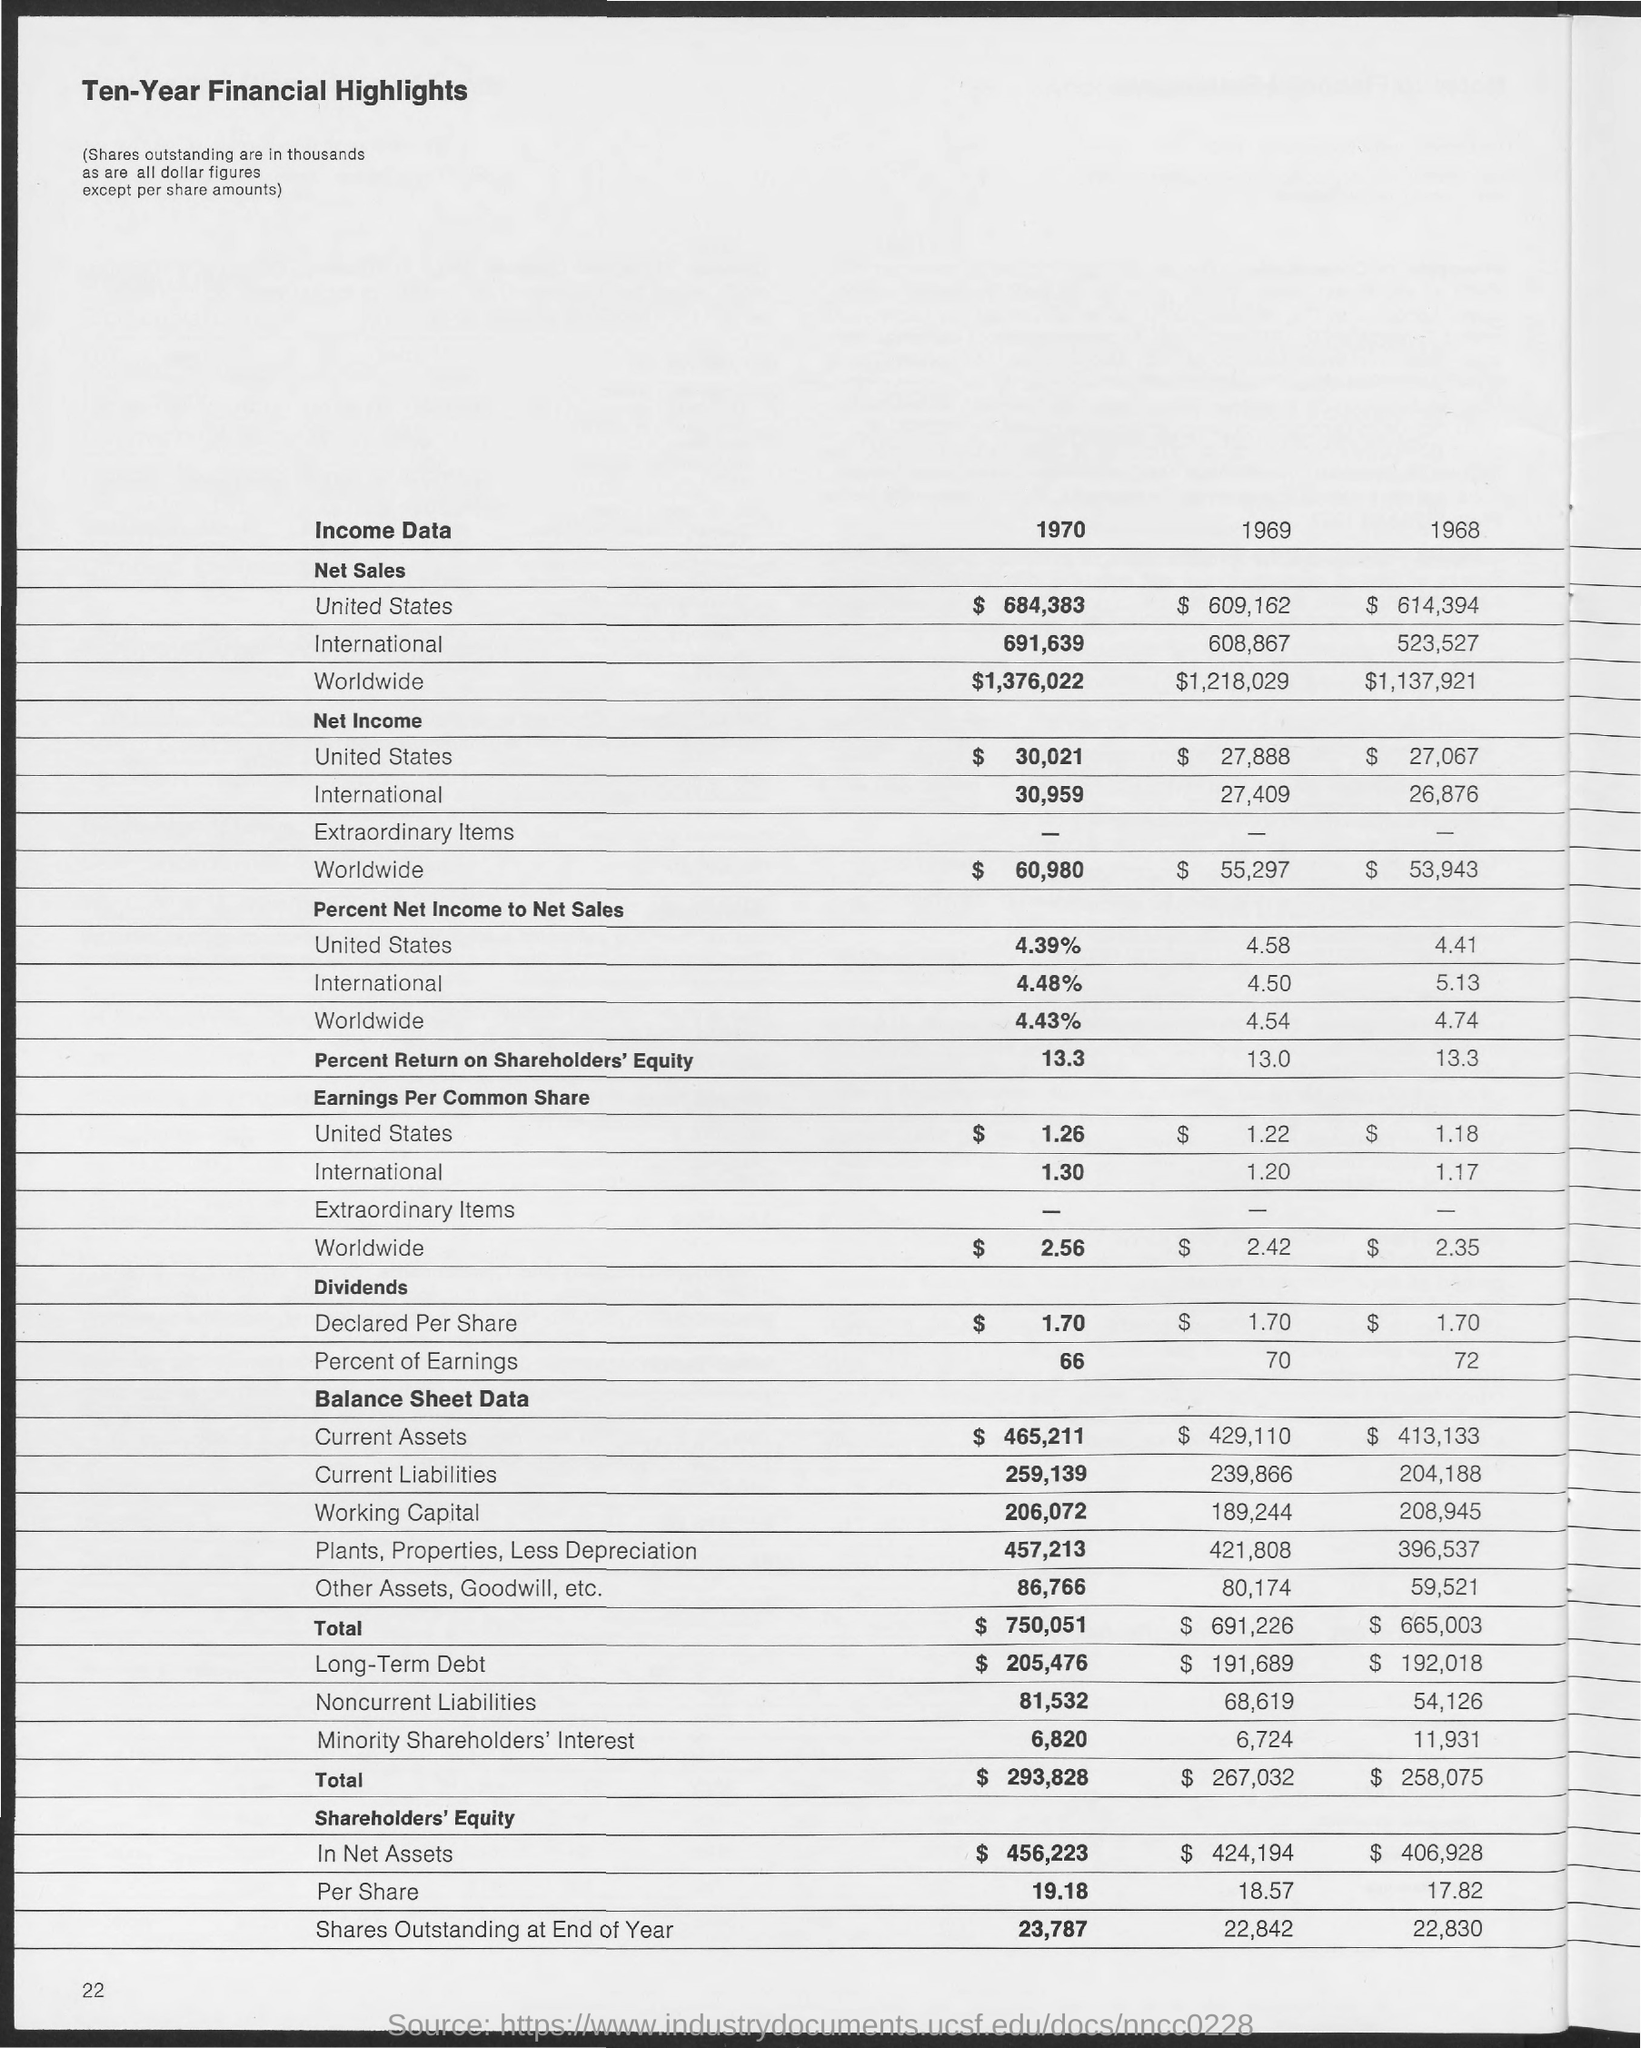Outline some significant characteristics in this image. In 1970, the net sales for the United States was $684,383. In 1968, the net sales for the United States were $614,394. In 1970, the net sales for Worldwide were $1,376,022. The net income for Worldwide in 1970 was $60,980. The net sales for Worldwide in 1968 were 1,137,921. 